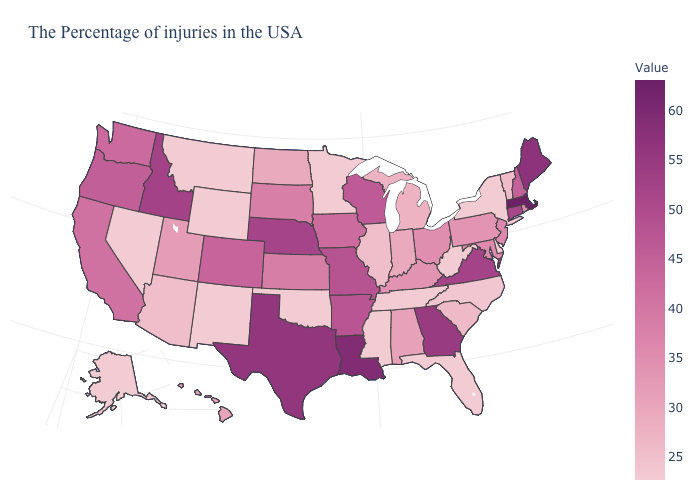Among the states that border Pennsylvania , which have the lowest value?
Answer briefly. New York, Delaware, West Virginia. Does Montana have a higher value than California?
Write a very short answer. No. Does North Carolina have the highest value in the USA?
Concise answer only. No. Which states have the lowest value in the Northeast?
Give a very brief answer. New York. Does Pennsylvania have the lowest value in the USA?
Answer briefly. No. Does Louisiana have the highest value in the South?
Give a very brief answer. Yes. Does Wisconsin have a lower value than Utah?
Keep it brief. No. Among the states that border Virginia , does North Carolina have the lowest value?
Quick response, please. No. 